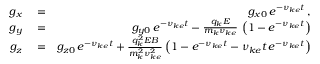Convert formula to latex. <formula><loc_0><loc_0><loc_500><loc_500>\begin{array} { r l r } { g _ { x } } & = } & { g _ { x 0 } \, e ^ { - \nu _ { k e } t } \, , } \\ { g _ { y } } & = } & { g _ { y 0 } \, e ^ { - \nu _ { k e } t } - \frac { q _ { k } E } { m _ { k } \nu _ { k e } } \, \left ( 1 - e ^ { - \nu _ { k e } t } \right ) } \\ { g _ { z } } & = } & { g _ { z 0 } \, e ^ { - \nu _ { k e } t } + \frac { q _ { k } ^ { 2 } E B } { m _ { k } ^ { 2 } \nu _ { k e } ^ { 2 } } \left ( 1 - e ^ { - \nu _ { k e } t } - \nu _ { k e } t \, e ^ { - \nu _ { k e } t } \right ) } \end{array}</formula> 